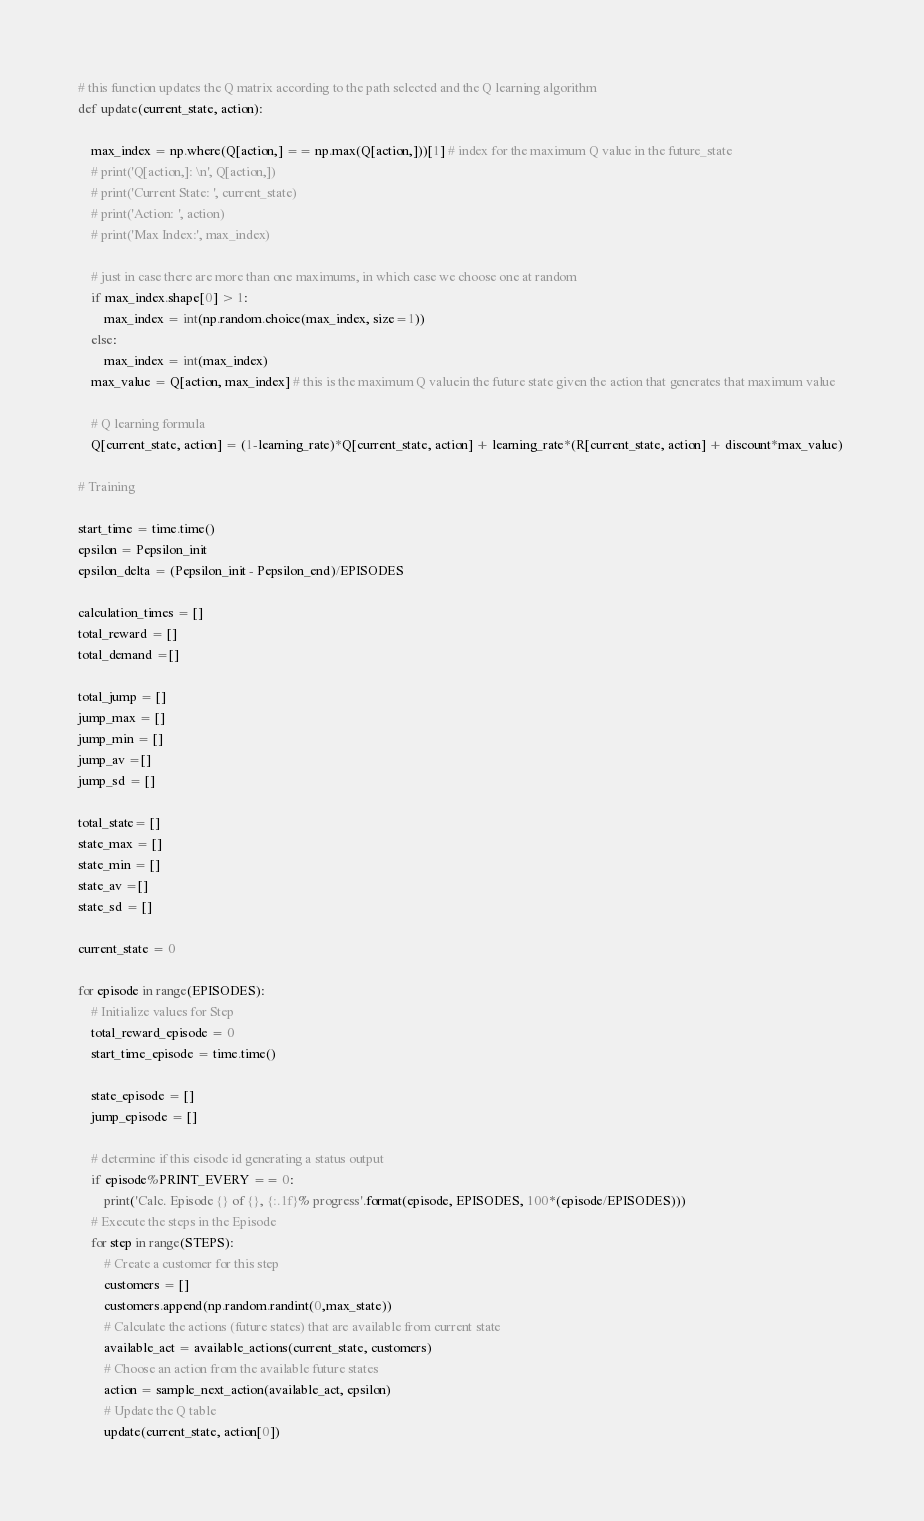Convert code to text. <code><loc_0><loc_0><loc_500><loc_500><_Python_># this function updates the Q matrix according to the path selected and the Q learning algorithm
def update(current_state, action):
   
    max_index = np.where(Q[action,] == np.max(Q[action,]))[1] # index for the maximum Q value in the future_state
    # print('Q[action,]: \n', Q[action,])
    # print('Current State: ', current_state)
    # print('Action: ', action)
    # print('Max Index:', max_index)
    
    # just in case there are more than one maximums, in which case we choose one at random
    if max_index.shape[0] > 1:
        max_index = int(np.random.choice(max_index, size=1))
    else:
        max_index = int(max_index)
    max_value = Q[action, max_index] # this is the maximum Q valuein the future state given the action that generates that maximum value
    
    # Q learning formula
    Q[current_state, action] = (1-learning_rate)*Q[current_state, action] + learning_rate*(R[current_state, action] + discount*max_value) 
    
# Training

start_time = time.time()
epsilon = Pepsilon_init
epsilon_delta = (Pepsilon_init - Pepsilon_end)/EPISODES

calculation_times = []
total_reward = []
total_demand =[]

total_jump = []
jump_max = []
jump_min = []
jump_av =[]
jump_sd = []

total_state= []
state_max = []
state_min = []
state_av =[]
state_sd = []

current_state = 0

for episode in range(EPISODES):
    # Initialize values for Step
    total_reward_episode = 0
    start_time_episode = time.time()
    
    state_episode = []
    jump_episode = []

    # determine if this eisode id generating a status output
    if episode%PRINT_EVERY == 0:
        print('Calc. Episode {} of {}, {:.1f}% progress'.format(episode, EPISODES, 100*(episode/EPISODES)))
    # Execute the steps in the Episode    
    for step in range(STEPS):
        # Create a customer for this step
        customers = []
        customers.append(np.random.randint(0,max_state))
        # Calculate the actions (future states) that are available from current state
        available_act = available_actions(current_state, customers)
        # Choose an action from the available future states
        action = sample_next_action(available_act, epsilon)
        # Update the Q table 
        update(current_state, action[0])
</code> 